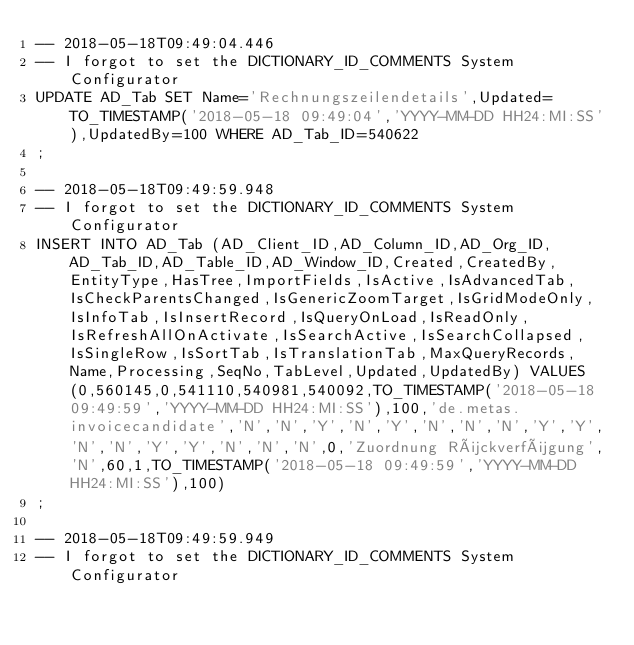Convert code to text. <code><loc_0><loc_0><loc_500><loc_500><_SQL_>-- 2018-05-18T09:49:04.446
-- I forgot to set the DICTIONARY_ID_COMMENTS System Configurator
UPDATE AD_Tab SET Name='Rechnungszeilendetails',Updated=TO_TIMESTAMP('2018-05-18 09:49:04','YYYY-MM-DD HH24:MI:SS'),UpdatedBy=100 WHERE AD_Tab_ID=540622
;

-- 2018-05-18T09:49:59.948
-- I forgot to set the DICTIONARY_ID_COMMENTS System Configurator
INSERT INTO AD_Tab (AD_Client_ID,AD_Column_ID,AD_Org_ID,AD_Tab_ID,AD_Table_ID,AD_Window_ID,Created,CreatedBy,EntityType,HasTree,ImportFields,IsActive,IsAdvancedTab,IsCheckParentsChanged,IsGenericZoomTarget,IsGridModeOnly,IsInfoTab,IsInsertRecord,IsQueryOnLoad,IsReadOnly,IsRefreshAllOnActivate,IsSearchActive,IsSearchCollapsed,IsSingleRow,IsSortTab,IsTranslationTab,MaxQueryRecords,Name,Processing,SeqNo,TabLevel,Updated,UpdatedBy) VALUES (0,560145,0,541110,540981,540092,TO_TIMESTAMP('2018-05-18 09:49:59','YYYY-MM-DD HH24:MI:SS'),100,'de.metas.invoicecandidate','N','N','Y','N','Y','N','N','N','Y','Y','N','N','Y','Y','N','N','N',0,'Zuordnung Rückverfügung','N',60,1,TO_TIMESTAMP('2018-05-18 09:49:59','YYYY-MM-DD HH24:MI:SS'),100)
;

-- 2018-05-18T09:49:59.949
-- I forgot to set the DICTIONARY_ID_COMMENTS System Configurator</code> 